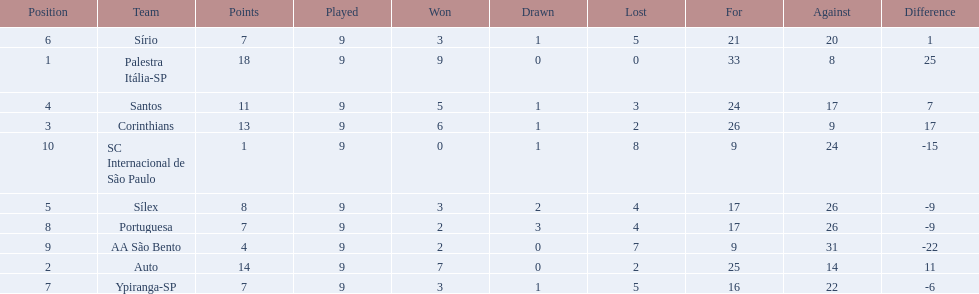What were the top three amounts of games won for 1926 in brazilian football season? 9, 7, 6. What were the top amount of games won for 1926 in brazilian football season? 9. What team won the top amount of games Palestra Itália-SP. 